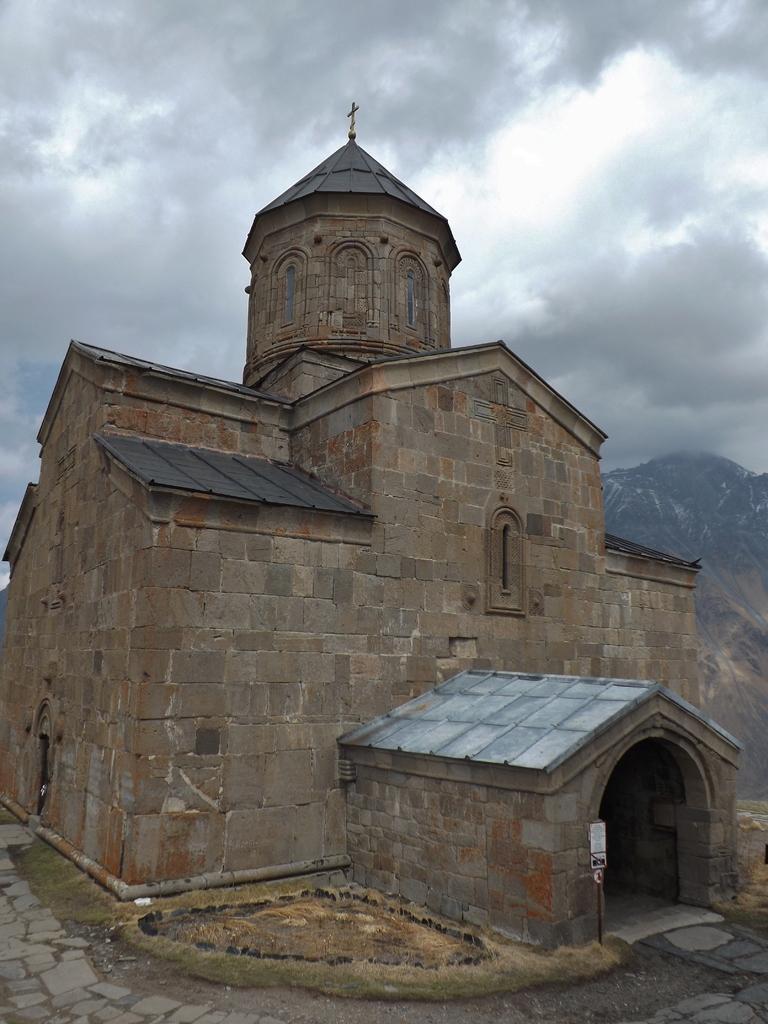Can you describe this image briefly? In this image, this looks like a church building. This is a board attached to a pole. I can see a holy cross symbol at the top of the spire. These are the clouds in the sky. 